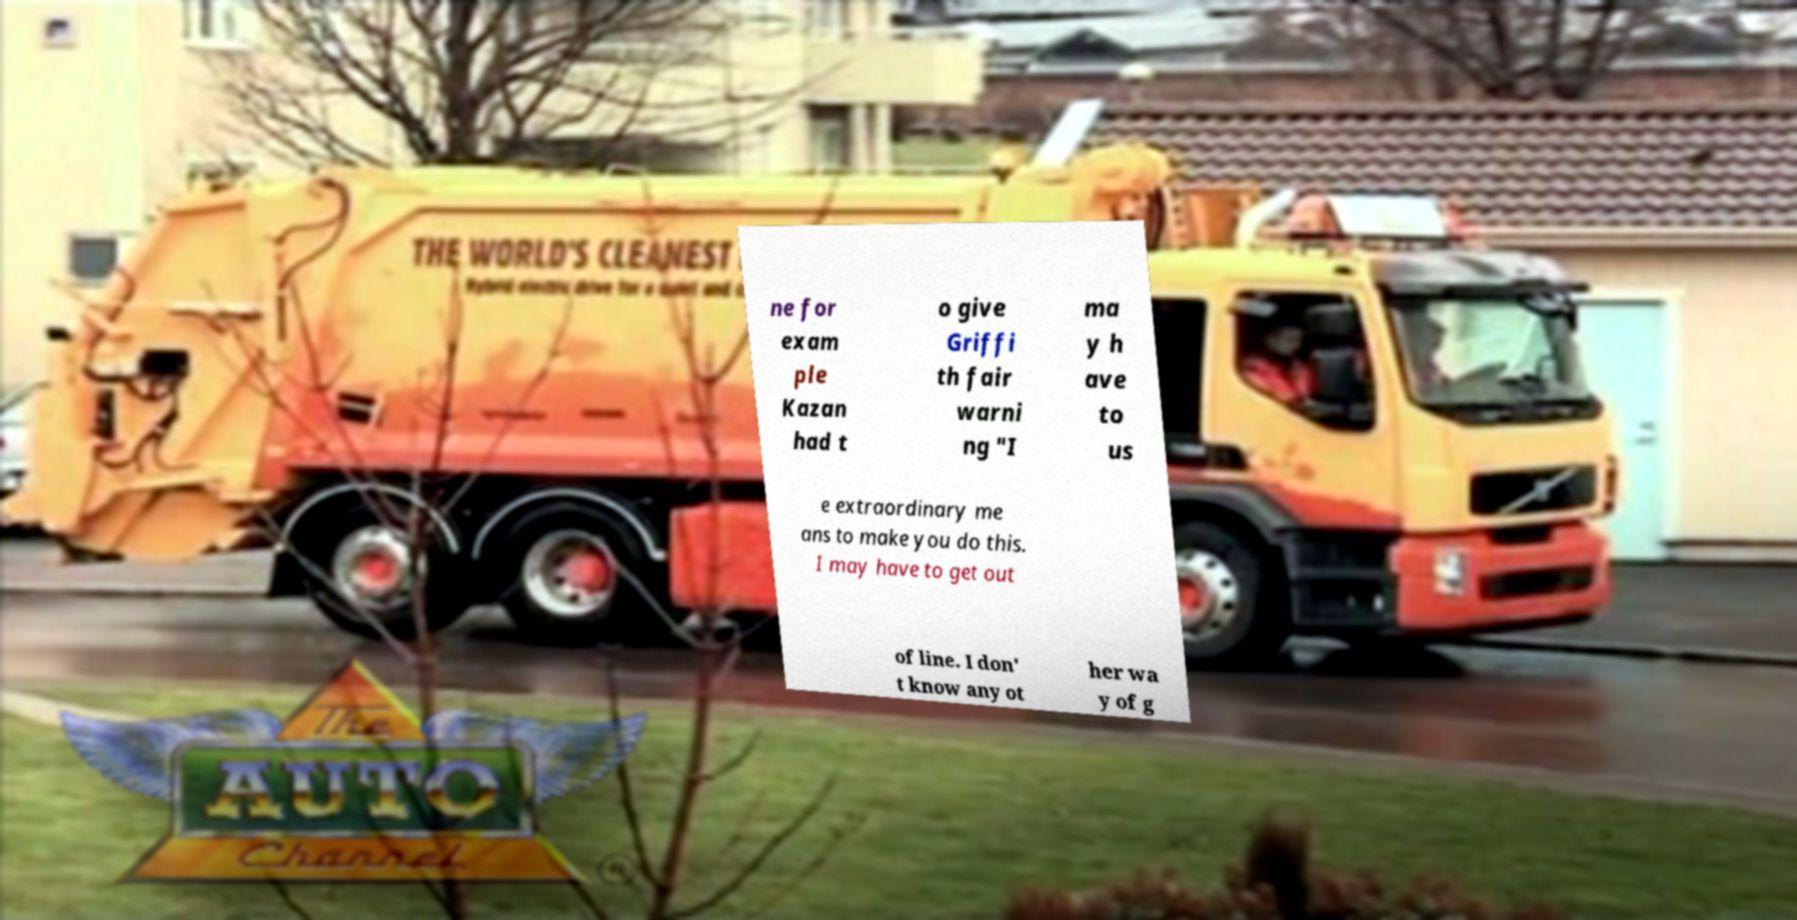Can you accurately transcribe the text from the provided image for me? ne for exam ple Kazan had t o give Griffi th fair warni ng "I ma y h ave to us e extraordinary me ans to make you do this. I may have to get out of line. I don' t know any ot her wa y of g 